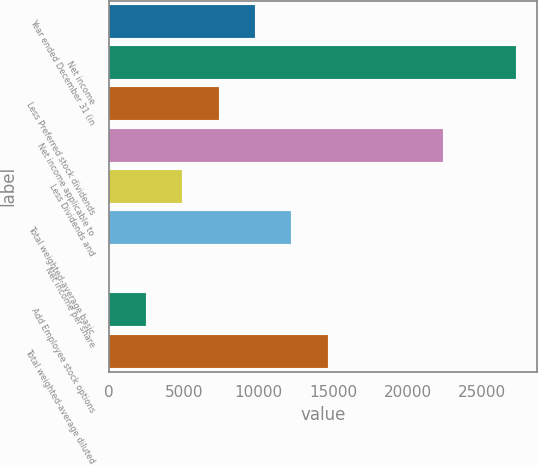Convert chart to OTSL. <chart><loc_0><loc_0><loc_500><loc_500><bar_chart><fcel>Year ended December 31 (in<fcel>Net income<fcel>Less Preferred stock dividends<fcel>Net income applicable to<fcel>Less Dividends and<fcel>Total weighted-average basic<fcel>Net income per share<fcel>Add Employee stock options<fcel>Total weighted-average diluted<nl><fcel>9780.44<fcel>27293.2<fcel>7336.85<fcel>22406<fcel>4893.25<fcel>12224<fcel>6.05<fcel>2449.65<fcel>14667.6<nl></chart> 